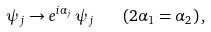<formula> <loc_0><loc_0><loc_500><loc_500>\psi _ { j } \rightarrow e ^ { i \alpha _ { j } } \, \psi _ { j } \quad ( 2 \alpha _ { 1 } = \alpha _ { 2 } ) \, ,</formula> 